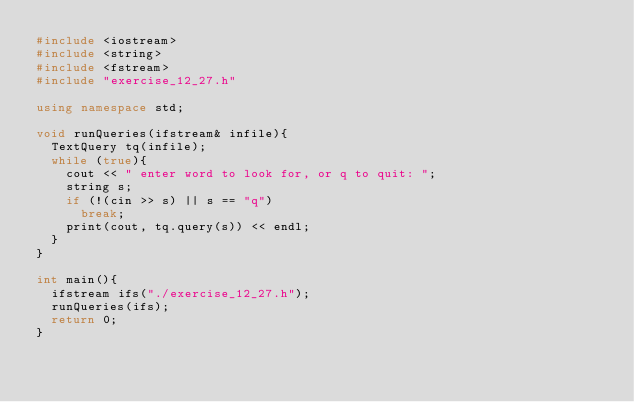<code> <loc_0><loc_0><loc_500><loc_500><_C++_>#include <iostream>
#include <string>
#include <fstream>
#include "exercise_12_27.h"

using namespace std;

void runQueries(ifstream& infile){
	TextQuery tq(infile);
	while (true){
		cout << " enter word to look for, or q to quit: ";
		string s;
		if (!(cin >> s) || s == "q")
			break;
		print(cout, tq.query(s)) << endl;
	}
}

int main(){
	ifstream ifs("./exercise_12_27.h");
	runQueries(ifs);
	return 0;
}
</code> 